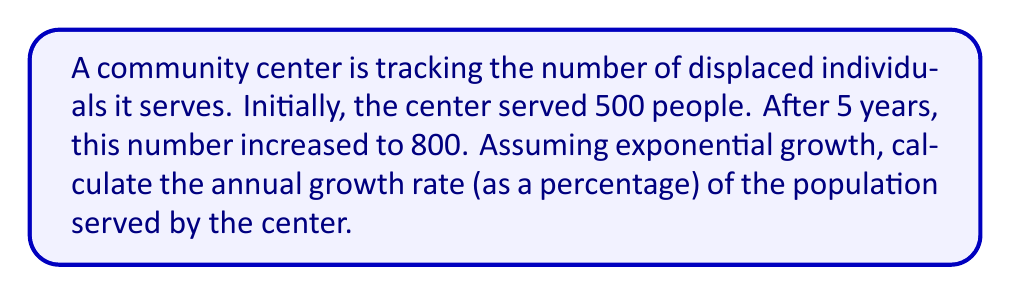What is the answer to this math problem? Let's approach this step-by-step using a logarithmic model:

1) The exponential growth formula is:
   $$P(t) = P_0 \cdot e^{rt}$$
   where $P(t)$ is the population at time $t$, $P_0$ is the initial population, $r$ is the growth rate, and $t$ is the time.

2) We know:
   $P_0 = 500$ (initial population)
   $P(5) = 800$ (population after 5 years)
   $t = 5$ years

3) Substituting into the formula:
   $$800 = 500 \cdot e^{5r}$$

4) Divide both sides by 500:
   $$\frac{800}{500} = e^{5r}$$

5) Take the natural logarithm of both sides:
   $$\ln(\frac{800}{500}) = \ln(e^{5r})$$

6) Simplify the right side using the logarithm property $\ln(e^x) = x$:
   $$\ln(\frac{800}{500}) = 5r$$

7) Solve for $r$:
   $$r = \frac{\ln(\frac{800}{500})}{5}$$

8) Calculate:
   $$r = \frac{\ln(1.6)}{5} \approx 0.0938$$

9) Convert to a percentage:
   $$0.0938 \cdot 100\% \approx 9.38\%$$
Answer: 9.38% 